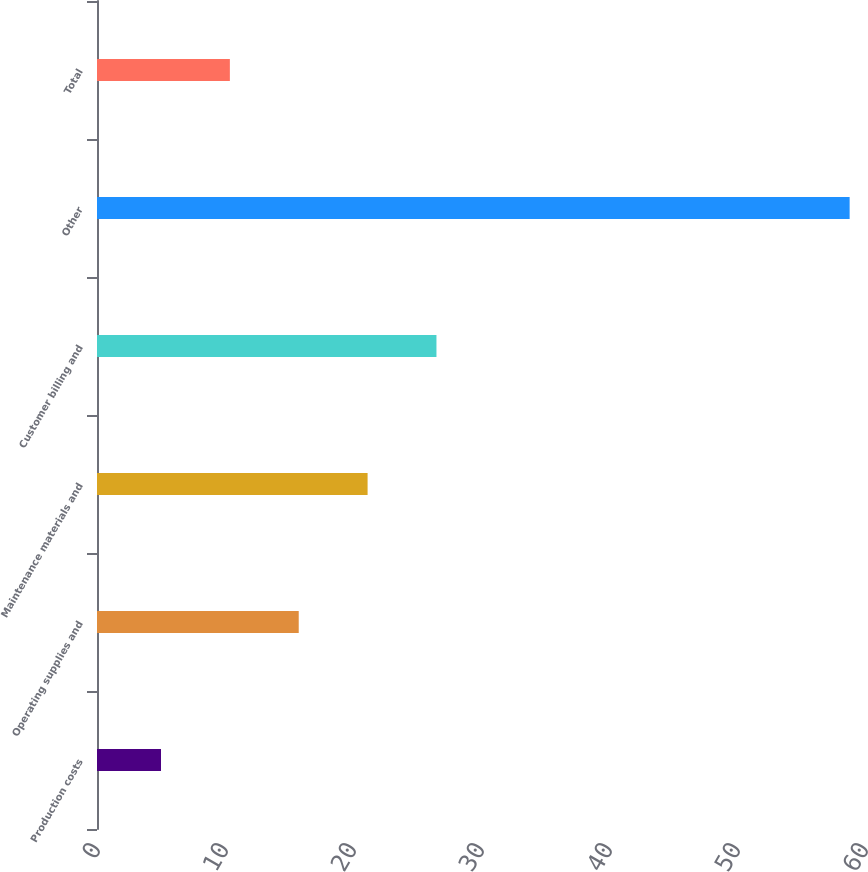<chart> <loc_0><loc_0><loc_500><loc_500><bar_chart><fcel>Production costs<fcel>Operating supplies and<fcel>Maintenance materials and<fcel>Customer billing and<fcel>Other<fcel>Total<nl><fcel>5<fcel>15.76<fcel>21.14<fcel>26.52<fcel>58.8<fcel>10.38<nl></chart> 